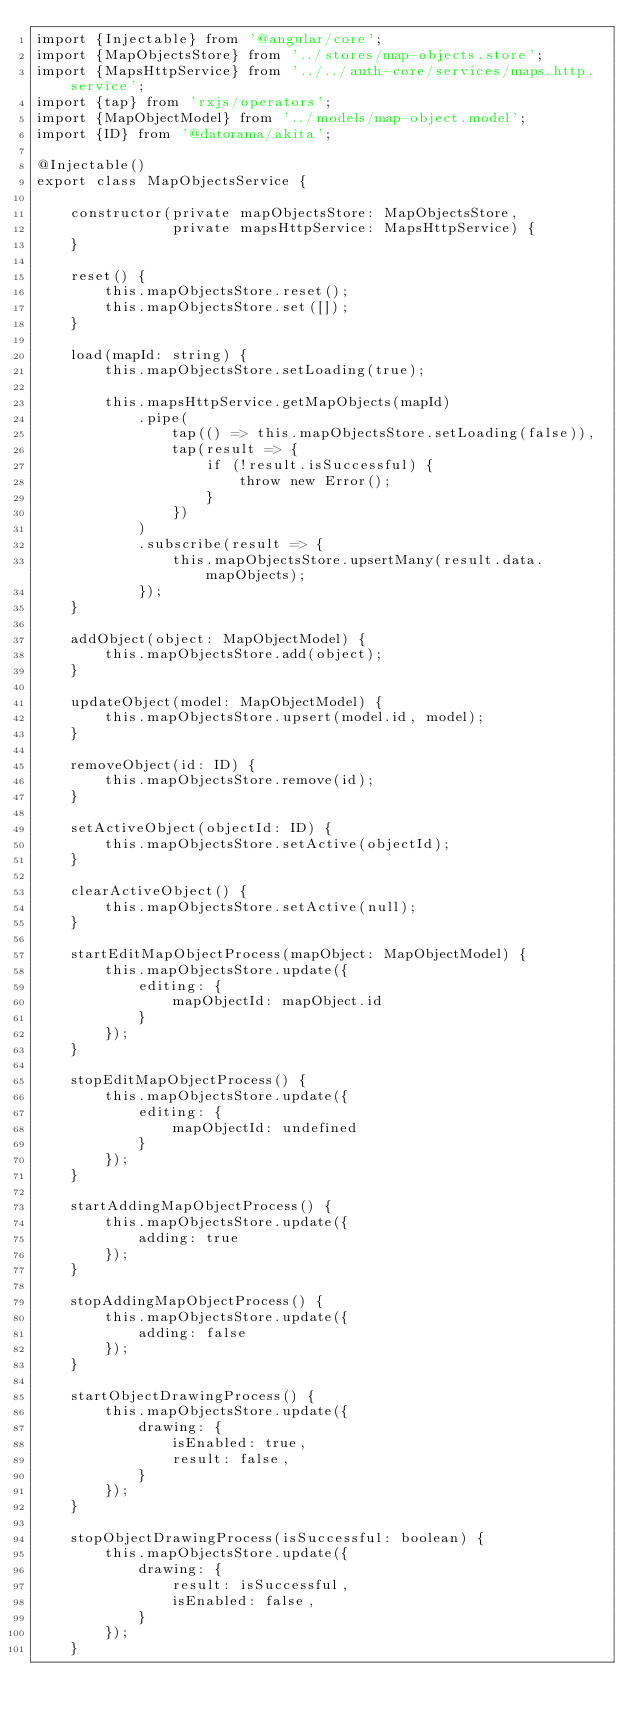<code> <loc_0><loc_0><loc_500><loc_500><_TypeScript_>import {Injectable} from '@angular/core';
import {MapObjectsStore} from '../stores/map-objects.store';
import {MapsHttpService} from '../../auth-core/services/maps.http.service';
import {tap} from 'rxjs/operators';
import {MapObjectModel} from '../models/map-object.model';
import {ID} from '@datorama/akita';

@Injectable()
export class MapObjectsService {

    constructor(private mapObjectsStore: MapObjectsStore,
                private mapsHttpService: MapsHttpService) {
    }

    reset() {
        this.mapObjectsStore.reset();
        this.mapObjectsStore.set([]);
    }

    load(mapId: string) {
        this.mapObjectsStore.setLoading(true);

        this.mapsHttpService.getMapObjects(mapId)
            .pipe(
                tap(() => this.mapObjectsStore.setLoading(false)),
                tap(result => {
                    if (!result.isSuccessful) {
                        throw new Error();
                    }
                })
            )
            .subscribe(result => {
                this.mapObjectsStore.upsertMany(result.data.mapObjects);
            });
    }

    addObject(object: MapObjectModel) {
        this.mapObjectsStore.add(object);
    }

    updateObject(model: MapObjectModel) {
        this.mapObjectsStore.upsert(model.id, model);
    }

    removeObject(id: ID) {
        this.mapObjectsStore.remove(id);
    }

    setActiveObject(objectId: ID) {
        this.mapObjectsStore.setActive(objectId);
    }

    clearActiveObject() {
        this.mapObjectsStore.setActive(null);
    }

    startEditMapObjectProcess(mapObject: MapObjectModel) {
        this.mapObjectsStore.update({
            editing: {
                mapObjectId: mapObject.id
            }
        });
    }

    stopEditMapObjectProcess() {
        this.mapObjectsStore.update({
            editing: {
                mapObjectId: undefined
            }
        });
    }

    startAddingMapObjectProcess() {
        this.mapObjectsStore.update({
            adding: true
        });
    }

    stopAddingMapObjectProcess() {
        this.mapObjectsStore.update({
            adding: false
        });
    }

    startObjectDrawingProcess() {
        this.mapObjectsStore.update({
            drawing: {
                isEnabled: true,
                result: false,
            }
        });
    }

    stopObjectDrawingProcess(isSuccessful: boolean) {
        this.mapObjectsStore.update({
            drawing: {
                result: isSuccessful,
                isEnabled: false,
            }
        });
    }
</code> 